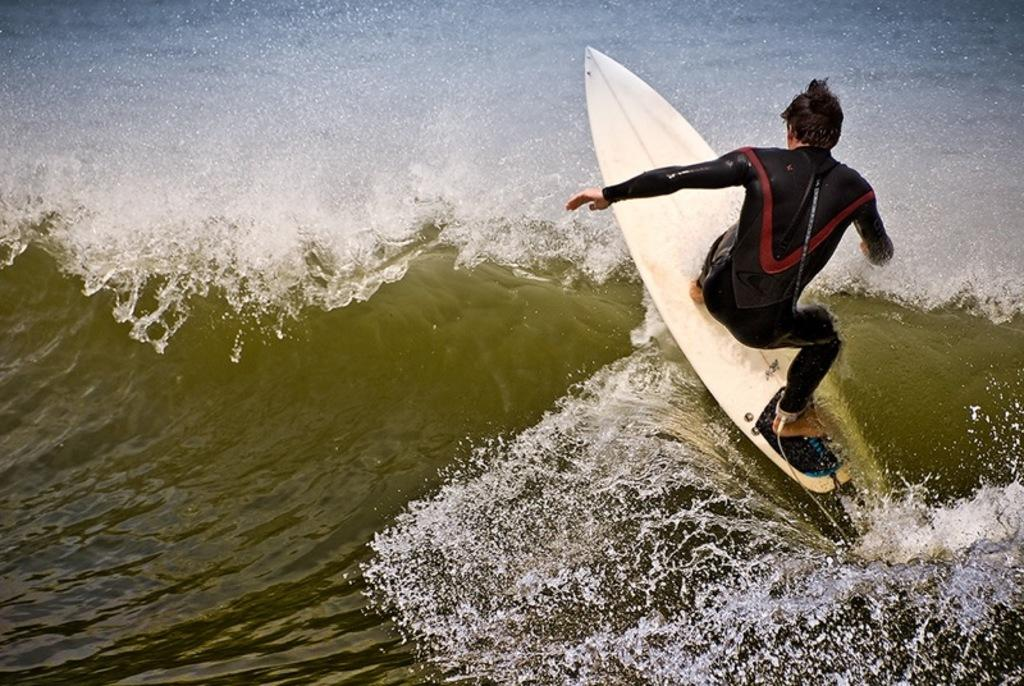What is the main subject of the image? The main subject of the image is a man. What is the man doing in the image? The man is surfing in the water. What color is the dress the man is wearing? The man is wearing a black color dress. Can you see any needles or stars in the image? No, there are no needles or stars present in the image. 